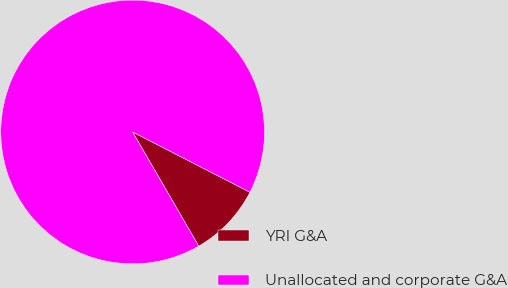<chart> <loc_0><loc_0><loc_500><loc_500><pie_chart><fcel>YRI G&A<fcel>Unallocated and corporate G&A<nl><fcel>9.09%<fcel>90.91%<nl></chart> 